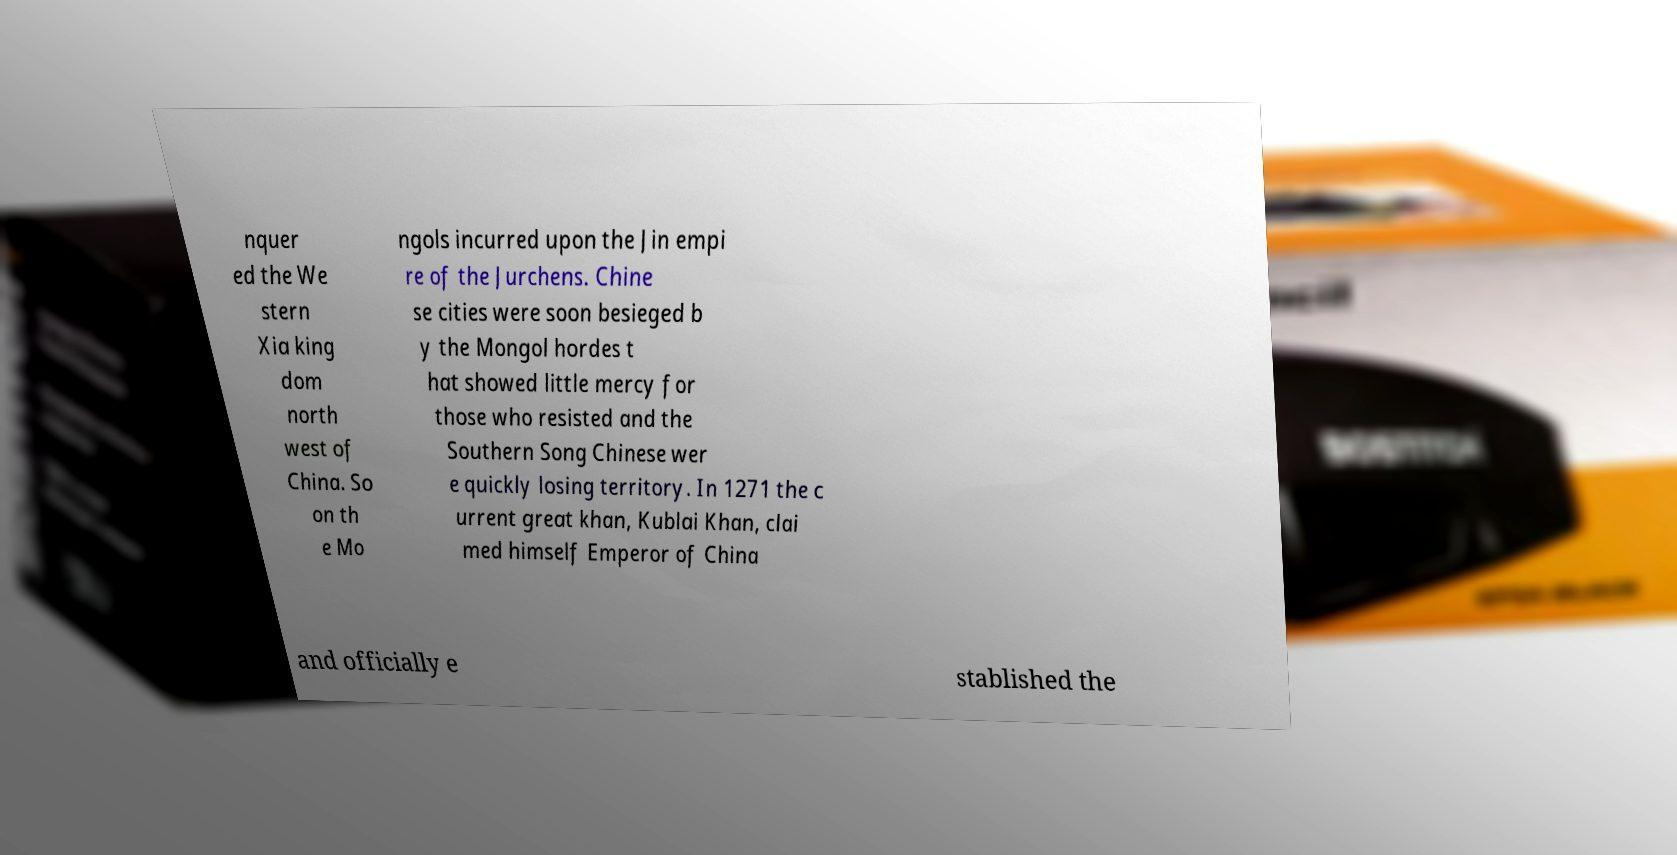There's text embedded in this image that I need extracted. Can you transcribe it verbatim? nquer ed the We stern Xia king dom north west of China. So on th e Mo ngols incurred upon the Jin empi re of the Jurchens. Chine se cities were soon besieged b y the Mongol hordes t hat showed little mercy for those who resisted and the Southern Song Chinese wer e quickly losing territory. In 1271 the c urrent great khan, Kublai Khan, clai med himself Emperor of China and officially e stablished the 